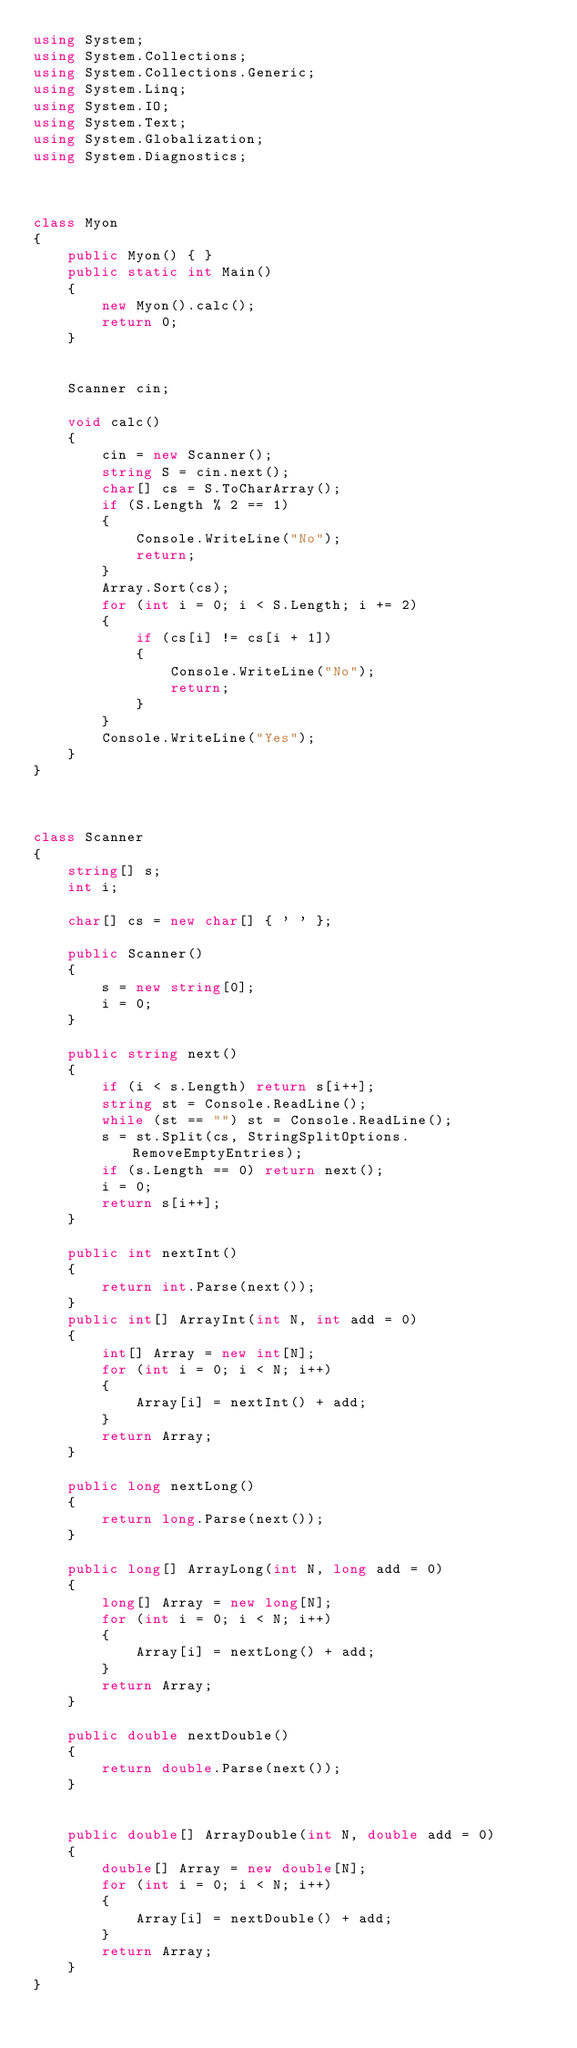<code> <loc_0><loc_0><loc_500><loc_500><_C#_>using System;
using System.Collections;
using System.Collections.Generic;
using System.Linq;
using System.IO;
using System.Text;
using System.Globalization;
using System.Diagnostics;



class Myon
{
    public Myon() { }
    public static int Main()
    {
        new Myon().calc();
        return 0;
    }


    Scanner cin;

    void calc()
    {
        cin = new Scanner();
        string S = cin.next();
        char[] cs = S.ToCharArray();
        if (S.Length % 2 == 1)
        {
            Console.WriteLine("No");
            return;
        }
        Array.Sort(cs);
        for (int i = 0; i < S.Length; i += 2)
        {
            if (cs[i] != cs[i + 1])
            {
                Console.WriteLine("No");
                return;
            }
        }
        Console.WriteLine("Yes");
    }
}



class Scanner
{
    string[] s;
    int i;

    char[] cs = new char[] { ' ' };

    public Scanner()
    {
        s = new string[0];
        i = 0;
    }

    public string next()
    {
        if (i < s.Length) return s[i++];
        string st = Console.ReadLine();
        while (st == "") st = Console.ReadLine();
        s = st.Split(cs, StringSplitOptions.RemoveEmptyEntries);
        if (s.Length == 0) return next();
        i = 0;
        return s[i++];
    }

    public int nextInt()
    {
        return int.Parse(next());
    }
    public int[] ArrayInt(int N, int add = 0)
    {
        int[] Array = new int[N];
        for (int i = 0; i < N; i++)
        {
            Array[i] = nextInt() + add;
        }
        return Array;
    }

    public long nextLong()
    {
        return long.Parse(next());
    }

    public long[] ArrayLong(int N, long add = 0)
    {
        long[] Array = new long[N];
        for (int i = 0; i < N; i++)
        {
            Array[i] = nextLong() + add;
        }
        return Array;
    }

    public double nextDouble()
    {
        return double.Parse(next());
    }


    public double[] ArrayDouble(int N, double add = 0)
    {
        double[] Array = new double[N];
        for (int i = 0; i < N; i++)
        {
            Array[i] = nextDouble() + add;
        }
        return Array;
    }
}
</code> 